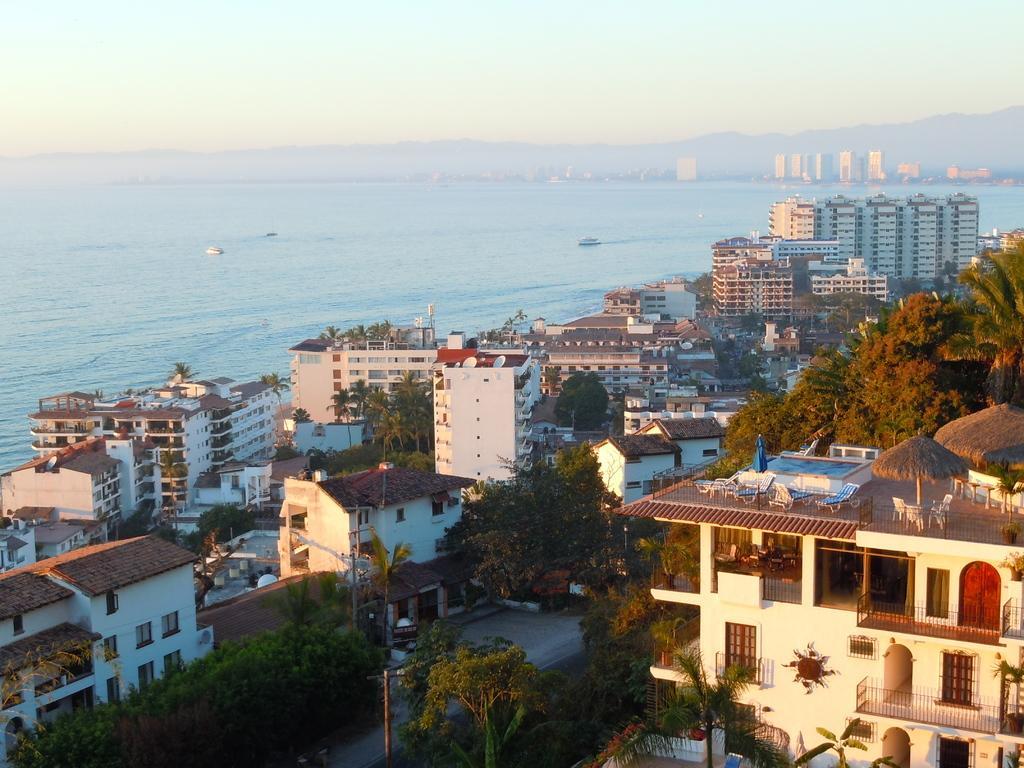Please provide a concise description of this image. This is an aerial view, in this there are houses, buildings, trees, in the background there is the sea, mountains and the sky. 